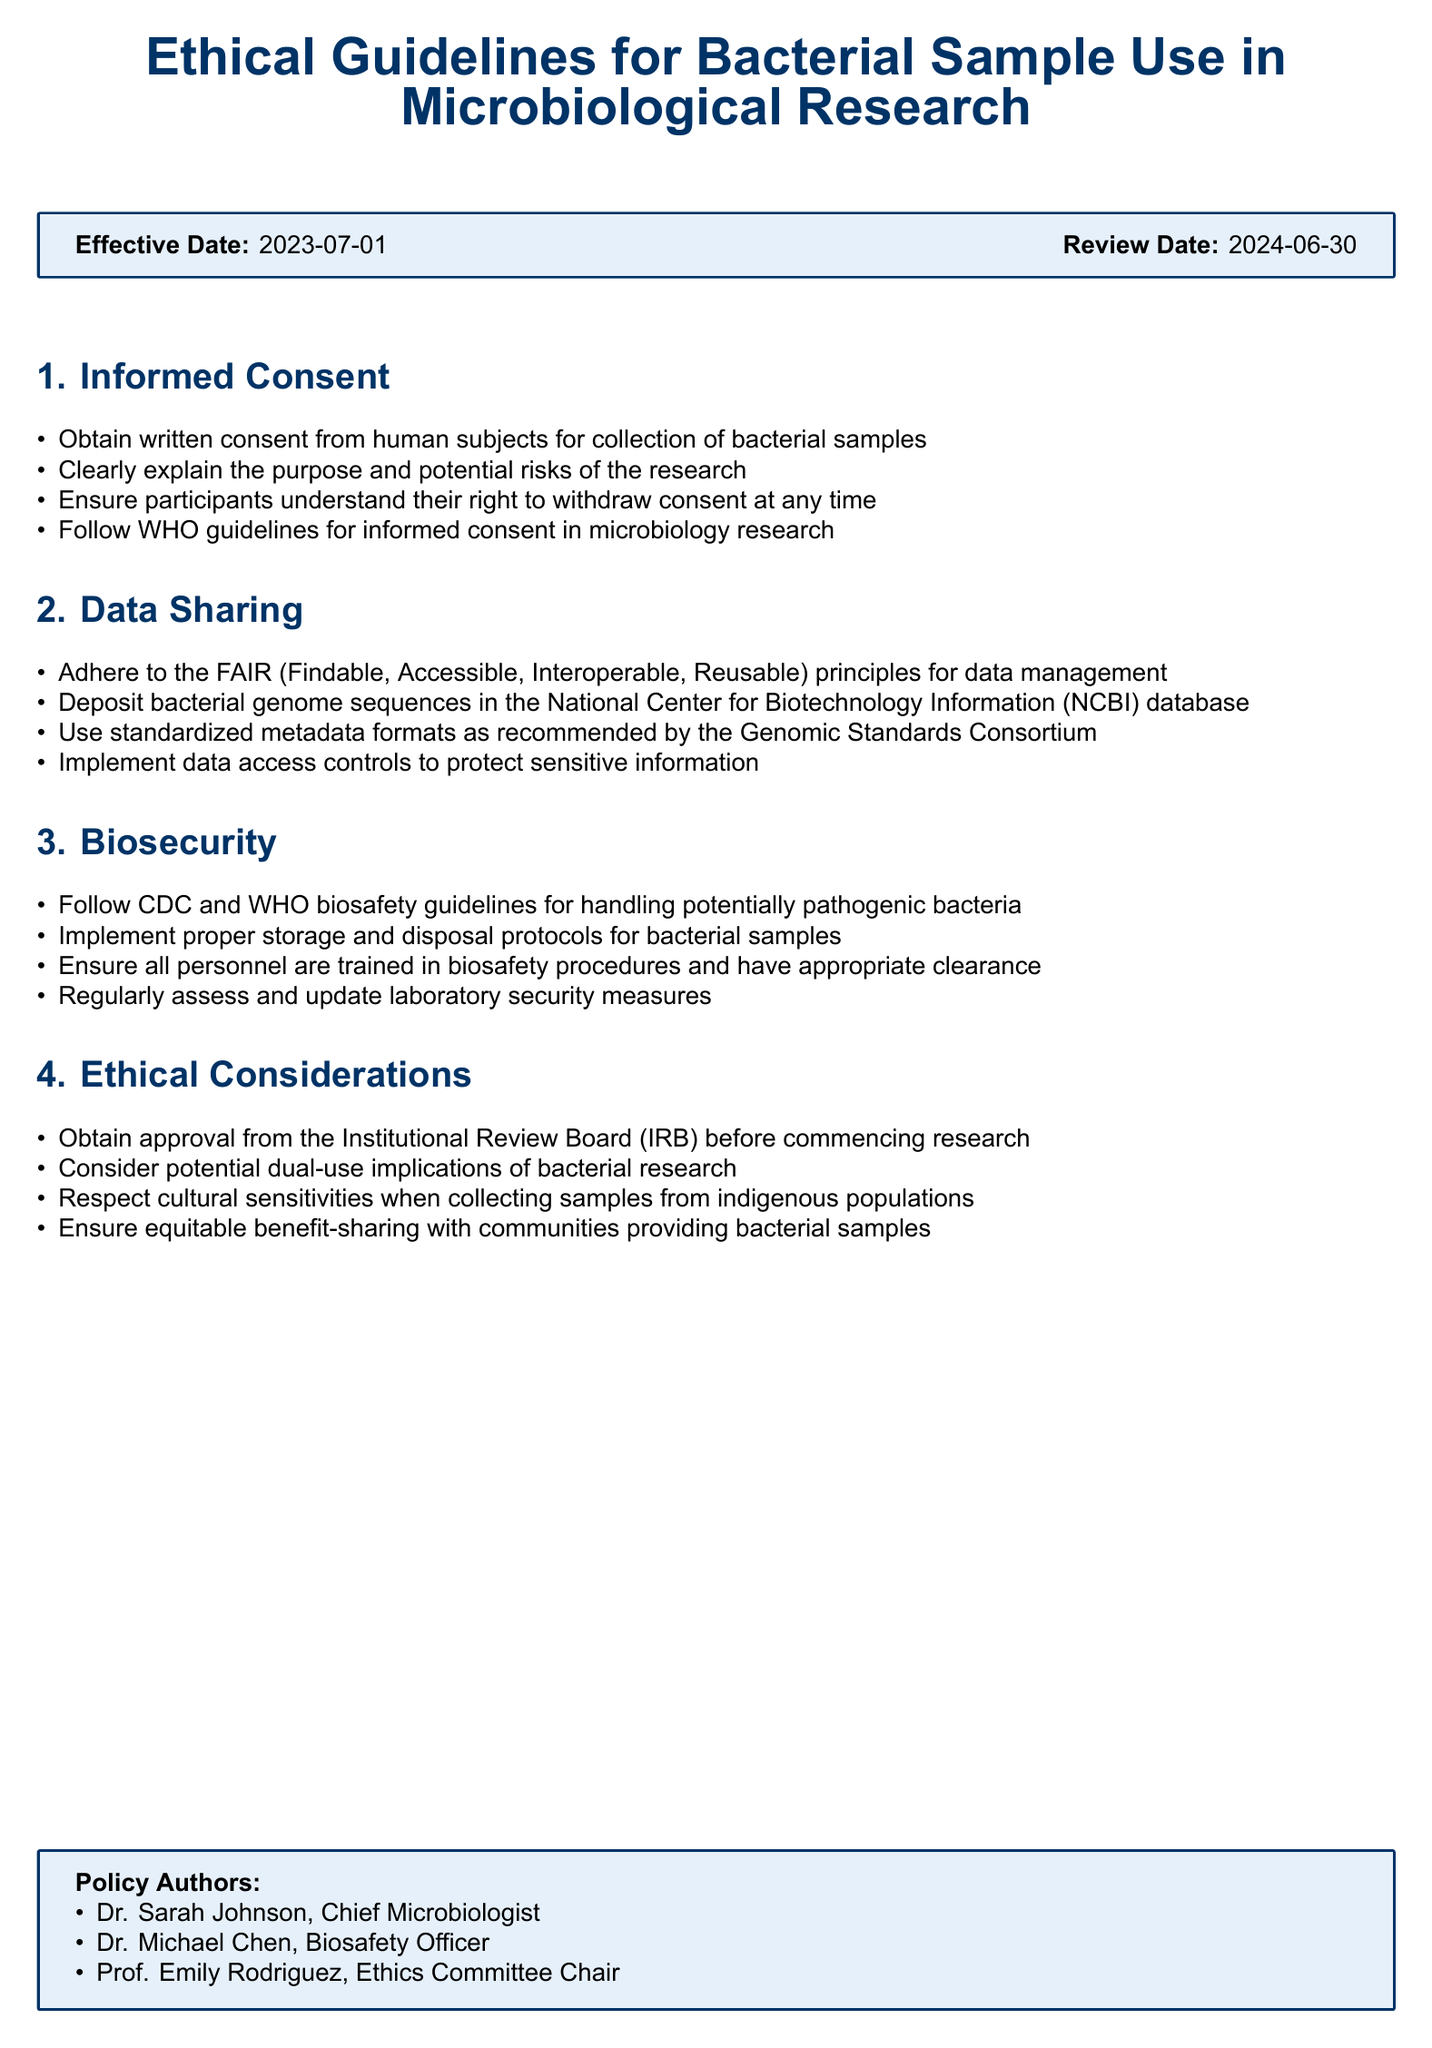What is the effective date of the policy? The effective date is stated prominently in the document.
Answer: 2023-07-01 Who is the Chief Microbiologist? The names of the policy authors are listed in a section at the end of the document.
Answer: Dr. Sarah Johnson What guidelines must be followed for informed consent? The document specifies that WHO guidelines for informed consent need to be followed.
Answer: WHO guidelines What principles should be adhered to for data management? The document lists the FAIR principles explicitly under the data sharing section.
Answer: FAIR principles What is required before commencing research? The ethical considerations section includes approval requirements from a specific board.
Answer: Institutional Review Board (IRB) Which database should bacterial genome sequences be deposited in? The data sharing section identifies the appropriate database for submissions.
Answer: National Center for Biotechnology Information (NCBI) What training is required for personnel handling bacterial samples? The document mentions training in biosafety procedures for personnel.
Answer: Biosafety procedures How often should laboratory security measures be assessed? Regular assessments are mentioned in the biosecurity section without a specific time frame.
Answer: Regularly What type of samples requires respect for cultural sensitivities? The ethical considerations make it clear that this applies to samples from a particular group.
Answer: Indigenous populations 